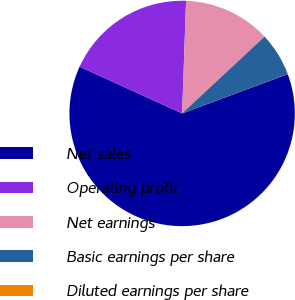<chart> <loc_0><loc_0><loc_500><loc_500><pie_chart><fcel>Net sales<fcel>Operating profit<fcel>Net earnings<fcel>Basic earnings per share<fcel>Diluted earnings per share<nl><fcel>62.49%<fcel>18.75%<fcel>12.5%<fcel>6.25%<fcel>0.01%<nl></chart> 